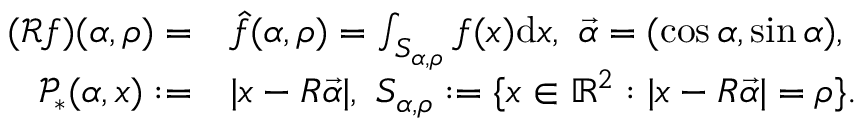Convert formula to latex. <formula><loc_0><loc_0><loc_500><loc_500>\begin{array} { r l } { ( \mathcal { R } f ) ( \alpha , \rho ) = } & { \hat { f } ( \alpha , \rho ) = \int _ { S _ { \alpha , \rho } } f ( x ) d x , \ \vec { \alpha } = ( \cos \alpha , \sin \alpha ) , } \\ { \mathcal { P } _ { * } ( \alpha , x ) \colon = } & { | x - R \vec { \alpha } | , \ S _ { \alpha , \rho } \colon = \{ x \in \mathbb { R } ^ { 2 } \colon | x - R \vec { \alpha } | = \rho \} . } \end{array}</formula> 